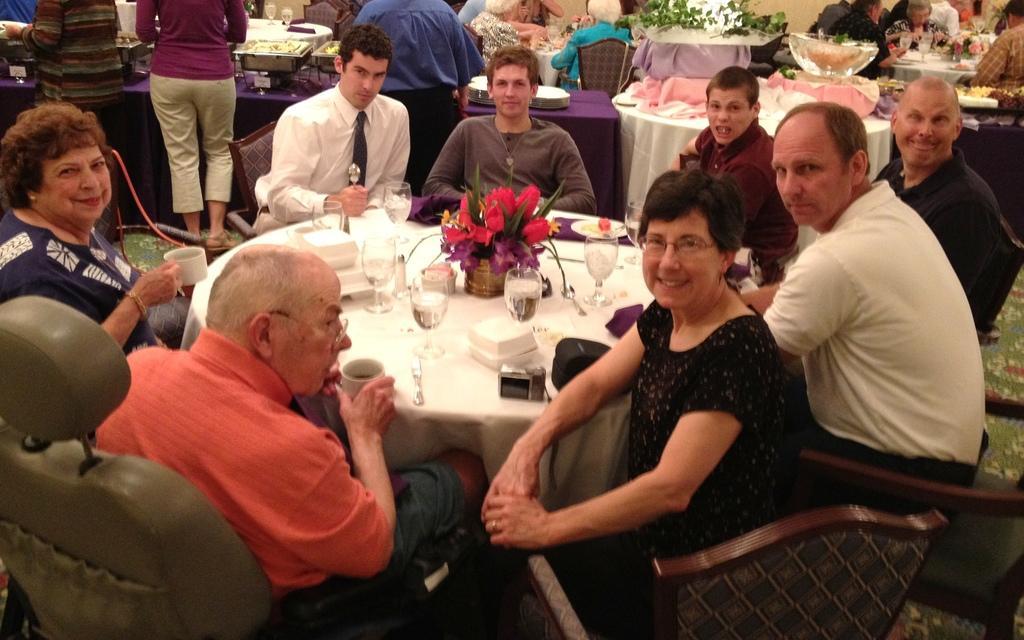Please provide a concise description of this image. In a picture it is a closed room where number of people are sitting on their chairs in front of a round table, where there are many glasses on it. Behind them there are some people eating and drinking and in the left corner of the picture there are three people standing, while in the left corner of the picture one old man is sitting and he is wearing a orange t-shirt and shorts and a cup in his hand. 